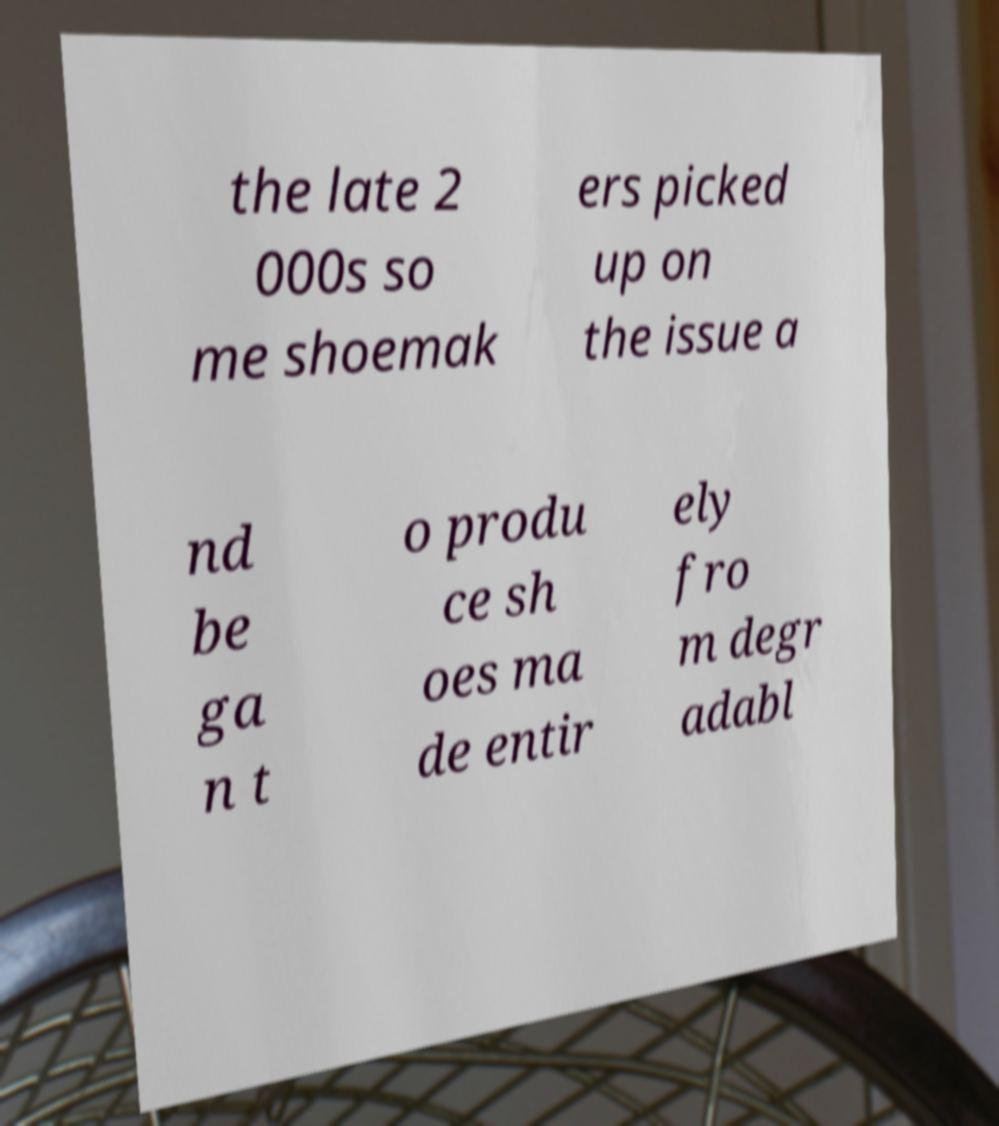There's text embedded in this image that I need extracted. Can you transcribe it verbatim? the late 2 000s so me shoemak ers picked up on the issue a nd be ga n t o produ ce sh oes ma de entir ely fro m degr adabl 